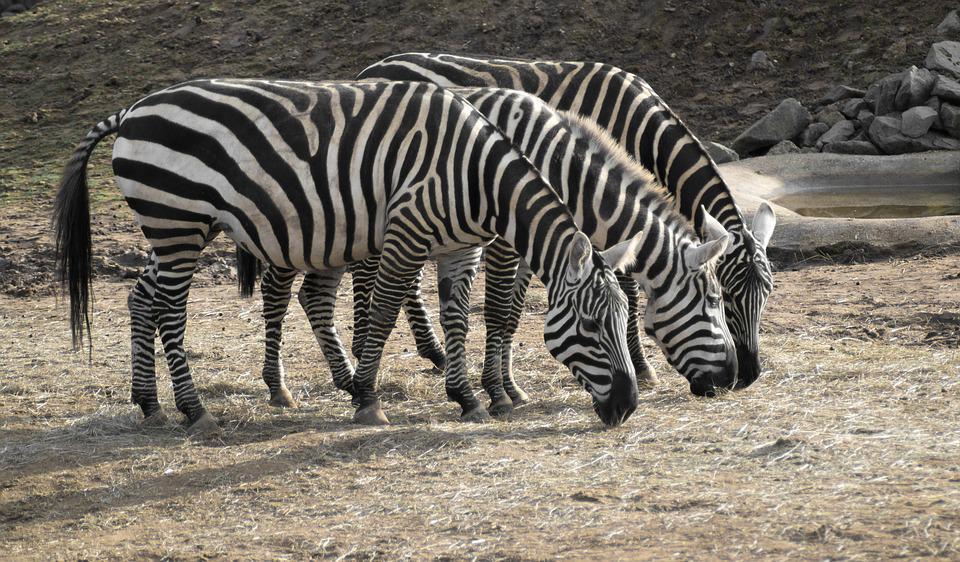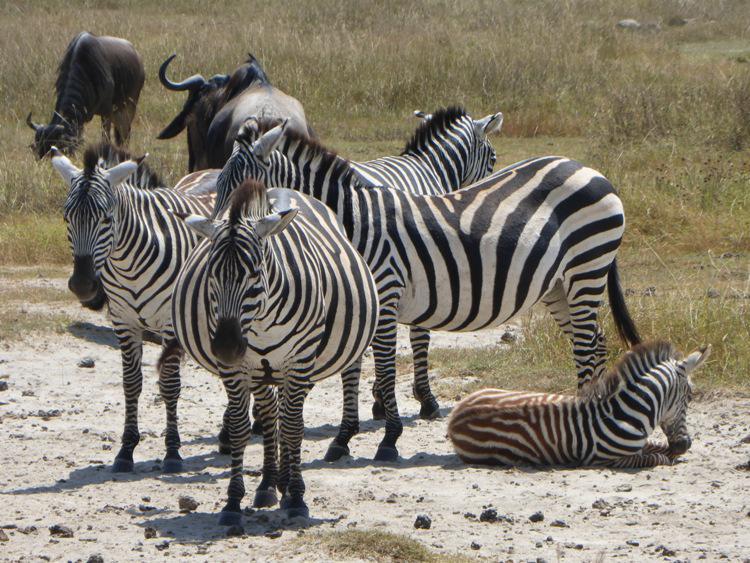The first image is the image on the left, the second image is the image on the right. Analyze the images presented: Is the assertion "In at least one image there is a baby zebra standing in front an adult zebra." valid? Answer yes or no. No. The first image is the image on the left, the second image is the image on the right. For the images shown, is this caption "There is a single zebra in at least one of the images." true? Answer yes or no. No. 